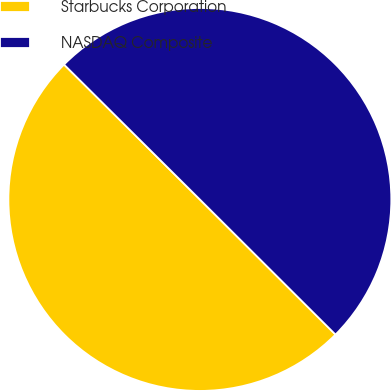<chart> <loc_0><loc_0><loc_500><loc_500><pie_chart><fcel>Starbucks Corporation<fcel>NASDAQ Composite<nl><fcel>49.98%<fcel>50.02%<nl></chart> 